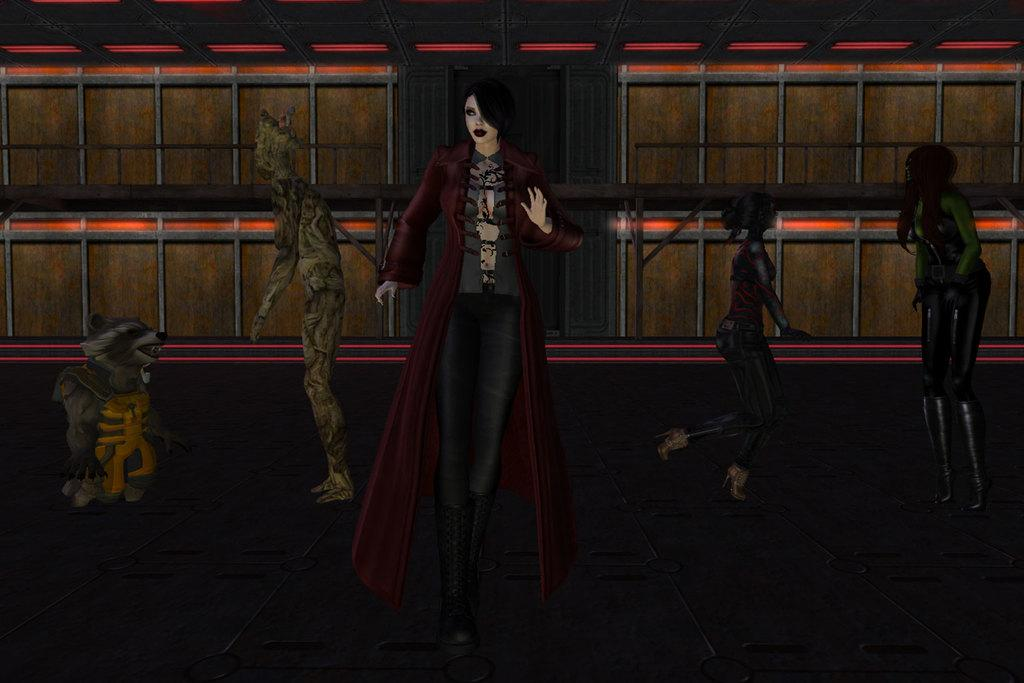What type of image is being described? The image is animated. Can you describe the characters in the image? There are people in the image. What is located on the left side of the image? There is an animal on the left side of the image. What can be seen in the background of the image? There is a wall in the background of the image. What type of instrument is the animal playing in the image? There is no instrument present in the image, and the animal is not shown playing any instrument. 